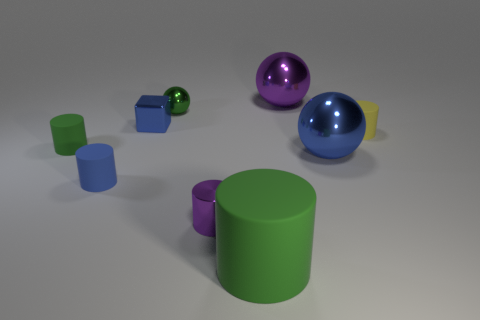What number of rubber objects are small brown spheres or big blue spheres?
Your response must be concise. 0. There is a big ball that is in front of the ball that is left of the large green rubber object; is there a tiny blue rubber thing that is to the right of it?
Give a very brief answer. No. There is a small yellow thing; what number of small green rubber cylinders are on the right side of it?
Provide a succinct answer. 0. There is a large sphere that is the same color as the small shiny cylinder; what material is it?
Your answer should be compact. Metal. How many big things are blue cylinders or gray shiny cubes?
Give a very brief answer. 0. There is a purple shiny thing that is to the right of the small purple metallic thing; what shape is it?
Provide a short and direct response. Sphere. Is there a small metallic object of the same color as the big rubber cylinder?
Give a very brief answer. Yes. There is a green matte cylinder to the right of the small block; does it have the same size as the shiny thing in front of the tiny blue matte thing?
Your answer should be compact. No. Is the number of yellow things that are left of the big purple sphere greater than the number of small green rubber cylinders right of the large blue ball?
Ensure brevity in your answer.  No. Is there a yellow sphere that has the same material as the purple sphere?
Provide a succinct answer. No. 